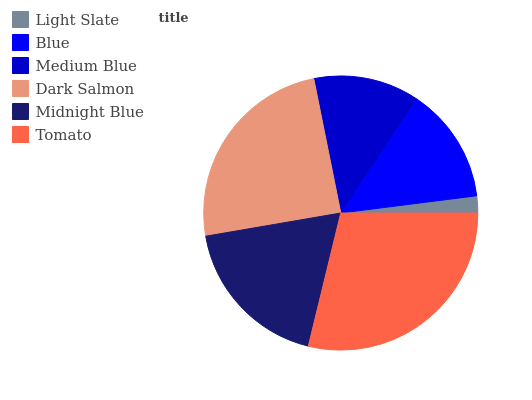Is Light Slate the minimum?
Answer yes or no. Yes. Is Tomato the maximum?
Answer yes or no. Yes. Is Blue the minimum?
Answer yes or no. No. Is Blue the maximum?
Answer yes or no. No. Is Blue greater than Light Slate?
Answer yes or no. Yes. Is Light Slate less than Blue?
Answer yes or no. Yes. Is Light Slate greater than Blue?
Answer yes or no. No. Is Blue less than Light Slate?
Answer yes or no. No. Is Midnight Blue the high median?
Answer yes or no. Yes. Is Blue the low median?
Answer yes or no. Yes. Is Dark Salmon the high median?
Answer yes or no. No. Is Light Slate the low median?
Answer yes or no. No. 